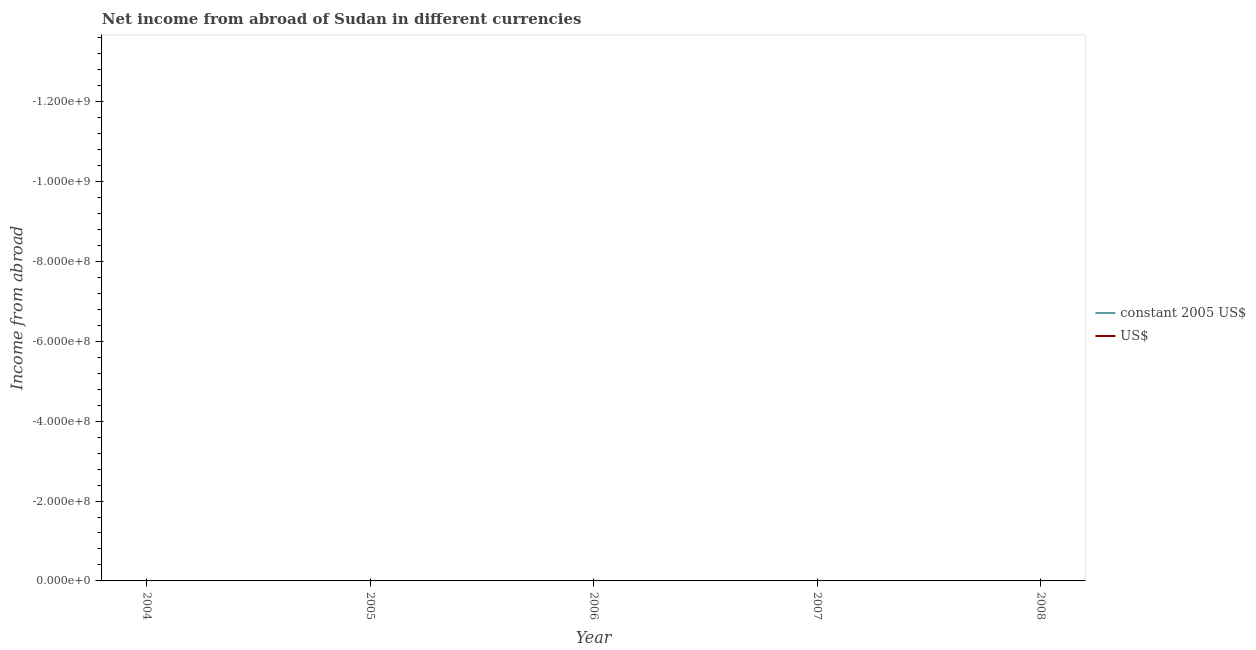How many different coloured lines are there?
Give a very brief answer. 0. Does the line corresponding to income from abroad in constant 2005 us$ intersect with the line corresponding to income from abroad in us$?
Your answer should be compact. No. Is the number of lines equal to the number of legend labels?
Your response must be concise. No. Across all years, what is the minimum income from abroad in constant 2005 us$?
Make the answer very short. 0. What is the total income from abroad in constant 2005 us$ in the graph?
Keep it short and to the point. 0. What is the difference between the income from abroad in us$ in 2005 and the income from abroad in constant 2005 us$ in 2007?
Give a very brief answer. 0. In how many years, is the income from abroad in constant 2005 us$ greater than the average income from abroad in constant 2005 us$ taken over all years?
Your response must be concise. 0. Does the income from abroad in us$ monotonically increase over the years?
Give a very brief answer. No. Is the income from abroad in constant 2005 us$ strictly less than the income from abroad in us$ over the years?
Provide a short and direct response. Yes. What is the difference between two consecutive major ticks on the Y-axis?
Ensure brevity in your answer.  2.00e+08. Are the values on the major ticks of Y-axis written in scientific E-notation?
Ensure brevity in your answer.  Yes. Does the graph contain grids?
Keep it short and to the point. No. How many legend labels are there?
Ensure brevity in your answer.  2. How are the legend labels stacked?
Keep it short and to the point. Vertical. What is the title of the graph?
Your answer should be very brief. Net income from abroad of Sudan in different currencies. Does "Netherlands" appear as one of the legend labels in the graph?
Provide a succinct answer. No. What is the label or title of the Y-axis?
Offer a very short reply. Income from abroad. What is the Income from abroad of constant 2005 US$ in 2004?
Ensure brevity in your answer.  0. What is the Income from abroad in US$ in 2004?
Your response must be concise. 0. What is the Income from abroad in constant 2005 US$ in 2005?
Give a very brief answer. 0. What is the Income from abroad of US$ in 2005?
Provide a short and direct response. 0. What is the Income from abroad of US$ in 2007?
Give a very brief answer. 0. What is the Income from abroad of US$ in 2008?
Offer a very short reply. 0. What is the total Income from abroad in constant 2005 US$ in the graph?
Provide a short and direct response. 0. What is the average Income from abroad of constant 2005 US$ per year?
Provide a succinct answer. 0. What is the average Income from abroad of US$ per year?
Offer a very short reply. 0. 